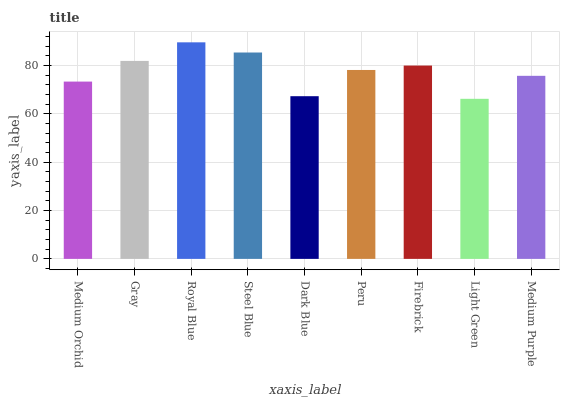Is Light Green the minimum?
Answer yes or no. Yes. Is Royal Blue the maximum?
Answer yes or no. Yes. Is Gray the minimum?
Answer yes or no. No. Is Gray the maximum?
Answer yes or no. No. Is Gray greater than Medium Orchid?
Answer yes or no. Yes. Is Medium Orchid less than Gray?
Answer yes or no. Yes. Is Medium Orchid greater than Gray?
Answer yes or no. No. Is Gray less than Medium Orchid?
Answer yes or no. No. Is Peru the high median?
Answer yes or no. Yes. Is Peru the low median?
Answer yes or no. Yes. Is Dark Blue the high median?
Answer yes or no. No. Is Light Green the low median?
Answer yes or no. No. 